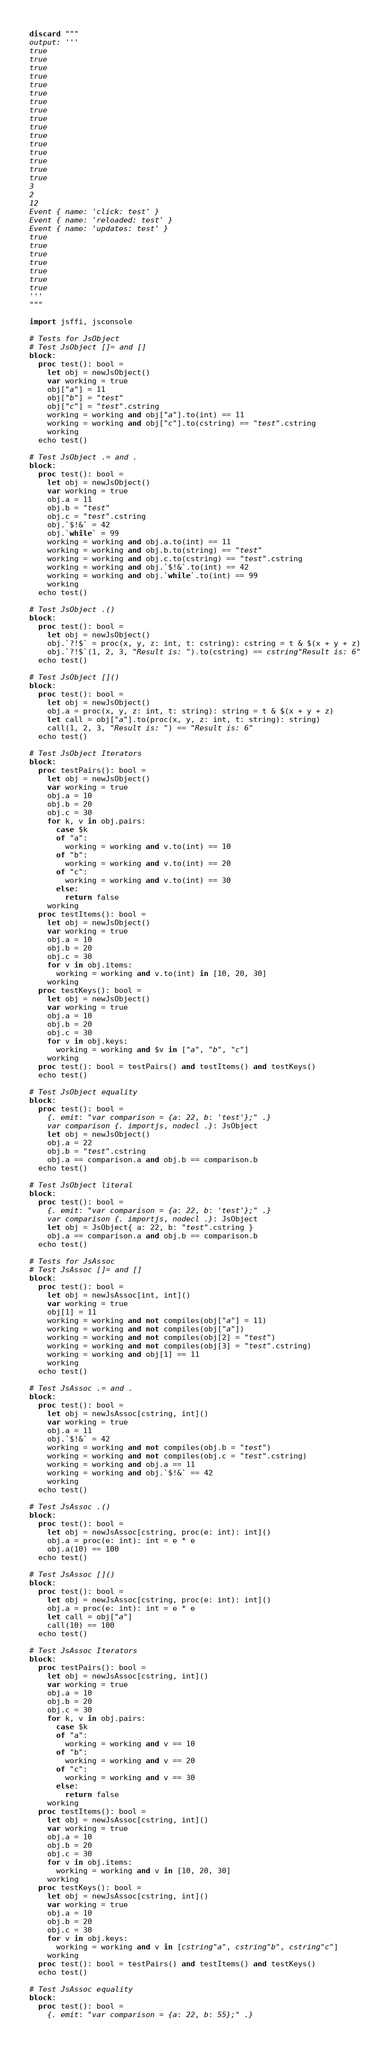<code> <loc_0><loc_0><loc_500><loc_500><_Nim_>discard """
output: '''
true
true
true
true
true
true
true
true
true
true
true
true
true
true
true
true
3
2
12
Event { name: 'click: test' }
Event { name: 'reloaded: test' }
Event { name: 'updates: test' }
true
true
true
true
true
true
true
'''
"""

import jsffi, jsconsole

# Tests for JsObject
# Test JsObject []= and []
block:
  proc test(): bool =
    let obj = newJsObject()
    var working = true
    obj["a"] = 11
    obj["b"] = "test"
    obj["c"] = "test".cstring
    working = working and obj["a"].to(int) == 11
    working = working and obj["c"].to(cstring) == "test".cstring
    working
  echo test()

# Test JsObject .= and .
block:
  proc test(): bool =
    let obj = newJsObject()
    var working = true
    obj.a = 11
    obj.b = "test"
    obj.c = "test".cstring
    obj.`$!&` = 42
    obj.`while` = 99
    working = working and obj.a.to(int) == 11
    working = working and obj.b.to(string) == "test"
    working = working and obj.c.to(cstring) == "test".cstring
    working = working and obj.`$!&`.to(int) == 42
    working = working and obj.`while`.to(int) == 99
    working
  echo test()

# Test JsObject .()
block:
  proc test(): bool =
    let obj = newJsObject()
    obj.`?!$` = proc(x, y, z: int, t: cstring): cstring = t & $(x + y + z)
    obj.`?!$`(1, 2, 3, "Result is: ").to(cstring) == cstring"Result is: 6"
  echo test()

# Test JsObject []()
block:
  proc test(): bool =
    let obj = newJsObject()
    obj.a = proc(x, y, z: int, t: string): string = t & $(x + y + z)
    let call = obj["a"].to(proc(x, y, z: int, t: string): string)
    call(1, 2, 3, "Result is: ") == "Result is: 6"
  echo test()

# Test JsObject Iterators
block:
  proc testPairs(): bool =
    let obj = newJsObject()
    var working = true
    obj.a = 10
    obj.b = 20
    obj.c = 30
    for k, v in obj.pairs:
      case $k
      of "a":
        working = working and v.to(int) == 10
      of "b":
        working = working and v.to(int) == 20
      of "c":
        working = working and v.to(int) == 30
      else:
        return false
    working
  proc testItems(): bool =
    let obj = newJsObject()
    var working = true
    obj.a = 10
    obj.b = 20
    obj.c = 30
    for v in obj.items:
      working = working and v.to(int) in [10, 20, 30]
    working
  proc testKeys(): bool =
    let obj = newJsObject()
    var working = true
    obj.a = 10
    obj.b = 20
    obj.c = 30
    for v in obj.keys:
      working = working and $v in ["a", "b", "c"]
    working
  proc test(): bool = testPairs() and testItems() and testKeys()
  echo test()

# Test JsObject equality
block:
  proc test(): bool =
    {. emit: "var comparison = {a: 22, b: 'test'};" .}
    var comparison {. importjs, nodecl .}: JsObject
    let obj = newJsObject()
    obj.a = 22
    obj.b = "test".cstring
    obj.a == comparison.a and obj.b == comparison.b
  echo test()

# Test JsObject literal
block:
  proc test(): bool =
    {. emit: "var comparison = {a: 22, b: 'test'};" .}
    var comparison {. importjs, nodecl .}: JsObject
    let obj = JsObject{ a: 22, b: "test".cstring }
    obj.a == comparison.a and obj.b == comparison.b
  echo test()

# Tests for JsAssoc
# Test JsAssoc []= and []
block:
  proc test(): bool =
    let obj = newJsAssoc[int, int]()
    var working = true
    obj[1] = 11
    working = working and not compiles(obj["a"] = 11)
    working = working and not compiles(obj["a"])
    working = working and not compiles(obj[2] = "test")
    working = working and not compiles(obj[3] = "test".cstring)
    working = working and obj[1] == 11
    working
  echo test()

# Test JsAssoc .= and .
block:
  proc test(): bool =
    let obj = newJsAssoc[cstring, int]()
    var working = true
    obj.a = 11
    obj.`$!&` = 42
    working = working and not compiles(obj.b = "test")
    working = working and not compiles(obj.c = "test".cstring)
    working = working and obj.a == 11
    working = working and obj.`$!&` == 42
    working
  echo test()

# Test JsAssoc .()
block:
  proc test(): bool =
    let obj = newJsAssoc[cstring, proc(e: int): int]()
    obj.a = proc(e: int): int = e * e
    obj.a(10) == 100
  echo test()

# Test JsAssoc []()
block:
  proc test(): bool =
    let obj = newJsAssoc[cstring, proc(e: int): int]()
    obj.a = proc(e: int): int = e * e
    let call = obj["a"]
    call(10) == 100
  echo test()

# Test JsAssoc Iterators
block:
  proc testPairs(): bool =
    let obj = newJsAssoc[cstring, int]()
    var working = true
    obj.a = 10
    obj.b = 20
    obj.c = 30
    for k, v in obj.pairs:
      case $k
      of "a":
        working = working and v == 10
      of "b":
        working = working and v == 20
      of "c":
        working = working and v == 30
      else:
        return false
    working
  proc testItems(): bool =
    let obj = newJsAssoc[cstring, int]()
    var working = true
    obj.a = 10
    obj.b = 20
    obj.c = 30
    for v in obj.items:
      working = working and v in [10, 20, 30]
    working
  proc testKeys(): bool =
    let obj = newJsAssoc[cstring, int]()
    var working = true
    obj.a = 10
    obj.b = 20
    obj.c = 30
    for v in obj.keys:
      working = working and v in [cstring"a", cstring"b", cstring"c"]
    working
  proc test(): bool = testPairs() and testItems() and testKeys()
  echo test()

# Test JsAssoc equality
block:
  proc test(): bool =
    {. emit: "var comparison = {a: 22, b: 55};" .}</code> 